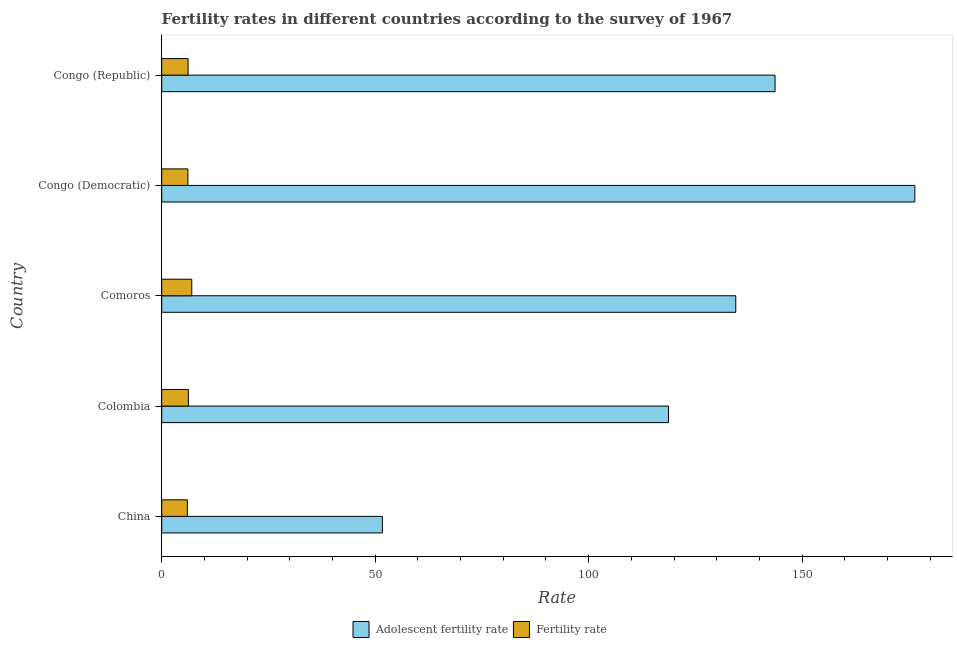How many different coloured bars are there?
Make the answer very short. 2. How many groups of bars are there?
Your response must be concise. 5. Are the number of bars on each tick of the Y-axis equal?
Provide a succinct answer. Yes. How many bars are there on the 2nd tick from the top?
Keep it short and to the point. 2. How many bars are there on the 2nd tick from the bottom?
Provide a succinct answer. 2. What is the label of the 3rd group of bars from the top?
Ensure brevity in your answer.  Comoros. What is the fertility rate in Congo (Democratic)?
Give a very brief answer. 6.13. Across all countries, what is the maximum adolescent fertility rate?
Offer a terse response. 176.4. Across all countries, what is the minimum adolescent fertility rate?
Your answer should be compact. 51.69. In which country was the fertility rate maximum?
Provide a short and direct response. Comoros. What is the total adolescent fertility rate in the graph?
Your response must be concise. 624.89. What is the difference between the adolescent fertility rate in Congo (Democratic) and that in Congo (Republic)?
Offer a very short reply. 32.74. What is the difference between the adolescent fertility rate in Colombia and the fertility rate in Congo (Republic)?
Give a very brief answer. 112.52. What is the average adolescent fertility rate per country?
Offer a very short reply. 124.98. What is the difference between the fertility rate and adolescent fertility rate in Congo (Republic)?
Your response must be concise. -137.48. What is the ratio of the adolescent fertility rate in Congo (Democratic) to that in Congo (Republic)?
Your response must be concise. 1.23. Is the difference between the fertility rate in Colombia and Comoros greater than the difference between the adolescent fertility rate in Colombia and Comoros?
Make the answer very short. Yes. What is the difference between the highest and the second highest fertility rate?
Your answer should be compact. 0.8. What is the difference between the highest and the lowest adolescent fertility rate?
Give a very brief answer. 124.71. In how many countries, is the adolescent fertility rate greater than the average adolescent fertility rate taken over all countries?
Give a very brief answer. 3. Is the sum of the adolescent fertility rate in Colombia and Comoros greater than the maximum fertility rate across all countries?
Your response must be concise. Yes. What does the 1st bar from the top in Comoros represents?
Make the answer very short. Fertility rate. What does the 1st bar from the bottom in Congo (Republic) represents?
Provide a succinct answer. Adolescent fertility rate. Are all the bars in the graph horizontal?
Ensure brevity in your answer.  Yes. How many countries are there in the graph?
Give a very brief answer. 5. How many legend labels are there?
Your answer should be compact. 2. How are the legend labels stacked?
Ensure brevity in your answer.  Horizontal. What is the title of the graph?
Your answer should be compact. Fertility rates in different countries according to the survey of 1967. What is the label or title of the X-axis?
Offer a very short reply. Rate. What is the Rate in Adolescent fertility rate in China?
Your answer should be compact. 51.69. What is the Rate in Fertility rate in China?
Your answer should be compact. 6.01. What is the Rate of Adolescent fertility rate in Colombia?
Give a very brief answer. 118.7. What is the Rate in Fertility rate in Colombia?
Make the answer very short. 6.25. What is the Rate of Adolescent fertility rate in Comoros?
Keep it short and to the point. 134.46. What is the Rate of Fertility rate in Comoros?
Make the answer very short. 7.04. What is the Rate in Adolescent fertility rate in Congo (Democratic)?
Make the answer very short. 176.4. What is the Rate of Fertility rate in Congo (Democratic)?
Make the answer very short. 6.13. What is the Rate of Adolescent fertility rate in Congo (Republic)?
Offer a very short reply. 143.65. What is the Rate in Fertility rate in Congo (Republic)?
Provide a succinct answer. 6.18. Across all countries, what is the maximum Rate of Adolescent fertility rate?
Make the answer very short. 176.4. Across all countries, what is the maximum Rate in Fertility rate?
Keep it short and to the point. 7.04. Across all countries, what is the minimum Rate of Adolescent fertility rate?
Your response must be concise. 51.69. Across all countries, what is the minimum Rate in Fertility rate?
Your response must be concise. 6.01. What is the total Rate of Adolescent fertility rate in the graph?
Your answer should be very brief. 624.89. What is the total Rate in Fertility rate in the graph?
Ensure brevity in your answer.  31.61. What is the difference between the Rate in Adolescent fertility rate in China and that in Colombia?
Offer a very short reply. -67.02. What is the difference between the Rate of Fertility rate in China and that in Colombia?
Offer a terse response. -0.23. What is the difference between the Rate in Adolescent fertility rate in China and that in Comoros?
Keep it short and to the point. -82.77. What is the difference between the Rate in Fertility rate in China and that in Comoros?
Your answer should be compact. -1.03. What is the difference between the Rate of Adolescent fertility rate in China and that in Congo (Democratic)?
Offer a very short reply. -124.71. What is the difference between the Rate of Fertility rate in China and that in Congo (Democratic)?
Ensure brevity in your answer.  -0.12. What is the difference between the Rate in Adolescent fertility rate in China and that in Congo (Republic)?
Your response must be concise. -91.97. What is the difference between the Rate of Fertility rate in China and that in Congo (Republic)?
Provide a short and direct response. -0.17. What is the difference between the Rate of Adolescent fertility rate in Colombia and that in Comoros?
Provide a succinct answer. -15.76. What is the difference between the Rate of Fertility rate in Colombia and that in Comoros?
Give a very brief answer. -0.8. What is the difference between the Rate in Adolescent fertility rate in Colombia and that in Congo (Democratic)?
Make the answer very short. -57.7. What is the difference between the Rate in Fertility rate in Colombia and that in Congo (Democratic)?
Offer a very short reply. 0.11. What is the difference between the Rate in Adolescent fertility rate in Colombia and that in Congo (Republic)?
Offer a very short reply. -24.95. What is the difference between the Rate in Fertility rate in Colombia and that in Congo (Republic)?
Offer a terse response. 0.07. What is the difference between the Rate of Adolescent fertility rate in Comoros and that in Congo (Democratic)?
Give a very brief answer. -41.94. What is the difference between the Rate in Fertility rate in Comoros and that in Congo (Democratic)?
Ensure brevity in your answer.  0.91. What is the difference between the Rate in Adolescent fertility rate in Comoros and that in Congo (Republic)?
Offer a terse response. -9.2. What is the difference between the Rate of Fertility rate in Comoros and that in Congo (Republic)?
Ensure brevity in your answer.  0.87. What is the difference between the Rate in Adolescent fertility rate in Congo (Democratic) and that in Congo (Republic)?
Your answer should be compact. 32.74. What is the difference between the Rate in Fertility rate in Congo (Democratic) and that in Congo (Republic)?
Your response must be concise. -0.04. What is the difference between the Rate in Adolescent fertility rate in China and the Rate in Fertility rate in Colombia?
Offer a terse response. 45.44. What is the difference between the Rate in Adolescent fertility rate in China and the Rate in Fertility rate in Comoros?
Provide a succinct answer. 44.64. What is the difference between the Rate of Adolescent fertility rate in China and the Rate of Fertility rate in Congo (Democratic)?
Give a very brief answer. 45.55. What is the difference between the Rate in Adolescent fertility rate in China and the Rate in Fertility rate in Congo (Republic)?
Offer a terse response. 45.51. What is the difference between the Rate in Adolescent fertility rate in Colombia and the Rate in Fertility rate in Comoros?
Offer a very short reply. 111.66. What is the difference between the Rate in Adolescent fertility rate in Colombia and the Rate in Fertility rate in Congo (Democratic)?
Ensure brevity in your answer.  112.56. What is the difference between the Rate in Adolescent fertility rate in Colombia and the Rate in Fertility rate in Congo (Republic)?
Provide a short and direct response. 112.52. What is the difference between the Rate of Adolescent fertility rate in Comoros and the Rate of Fertility rate in Congo (Democratic)?
Offer a terse response. 128.32. What is the difference between the Rate of Adolescent fertility rate in Comoros and the Rate of Fertility rate in Congo (Republic)?
Offer a very short reply. 128.28. What is the difference between the Rate of Adolescent fertility rate in Congo (Democratic) and the Rate of Fertility rate in Congo (Republic)?
Keep it short and to the point. 170.22. What is the average Rate of Adolescent fertility rate per country?
Your answer should be compact. 124.98. What is the average Rate of Fertility rate per country?
Offer a terse response. 6.32. What is the difference between the Rate of Adolescent fertility rate and Rate of Fertility rate in China?
Provide a succinct answer. 45.67. What is the difference between the Rate in Adolescent fertility rate and Rate in Fertility rate in Colombia?
Your answer should be very brief. 112.45. What is the difference between the Rate of Adolescent fertility rate and Rate of Fertility rate in Comoros?
Give a very brief answer. 127.41. What is the difference between the Rate of Adolescent fertility rate and Rate of Fertility rate in Congo (Democratic)?
Your answer should be very brief. 170.26. What is the difference between the Rate in Adolescent fertility rate and Rate in Fertility rate in Congo (Republic)?
Make the answer very short. 137.48. What is the ratio of the Rate in Adolescent fertility rate in China to that in Colombia?
Provide a short and direct response. 0.44. What is the ratio of the Rate in Fertility rate in China to that in Colombia?
Make the answer very short. 0.96. What is the ratio of the Rate of Adolescent fertility rate in China to that in Comoros?
Your response must be concise. 0.38. What is the ratio of the Rate in Fertility rate in China to that in Comoros?
Your answer should be compact. 0.85. What is the ratio of the Rate of Adolescent fertility rate in China to that in Congo (Democratic)?
Make the answer very short. 0.29. What is the ratio of the Rate of Fertility rate in China to that in Congo (Democratic)?
Give a very brief answer. 0.98. What is the ratio of the Rate of Adolescent fertility rate in China to that in Congo (Republic)?
Keep it short and to the point. 0.36. What is the ratio of the Rate in Fertility rate in China to that in Congo (Republic)?
Offer a terse response. 0.97. What is the ratio of the Rate of Adolescent fertility rate in Colombia to that in Comoros?
Offer a terse response. 0.88. What is the ratio of the Rate of Fertility rate in Colombia to that in Comoros?
Provide a succinct answer. 0.89. What is the ratio of the Rate in Adolescent fertility rate in Colombia to that in Congo (Democratic)?
Offer a terse response. 0.67. What is the ratio of the Rate of Fertility rate in Colombia to that in Congo (Democratic)?
Your answer should be very brief. 1.02. What is the ratio of the Rate of Adolescent fertility rate in Colombia to that in Congo (Republic)?
Give a very brief answer. 0.83. What is the ratio of the Rate of Fertility rate in Colombia to that in Congo (Republic)?
Keep it short and to the point. 1.01. What is the ratio of the Rate in Adolescent fertility rate in Comoros to that in Congo (Democratic)?
Your answer should be compact. 0.76. What is the ratio of the Rate in Fertility rate in Comoros to that in Congo (Democratic)?
Make the answer very short. 1.15. What is the ratio of the Rate in Adolescent fertility rate in Comoros to that in Congo (Republic)?
Offer a very short reply. 0.94. What is the ratio of the Rate in Fertility rate in Comoros to that in Congo (Republic)?
Make the answer very short. 1.14. What is the ratio of the Rate of Adolescent fertility rate in Congo (Democratic) to that in Congo (Republic)?
Give a very brief answer. 1.23. What is the difference between the highest and the second highest Rate of Adolescent fertility rate?
Your answer should be compact. 32.74. What is the difference between the highest and the second highest Rate in Fertility rate?
Offer a very short reply. 0.8. What is the difference between the highest and the lowest Rate of Adolescent fertility rate?
Give a very brief answer. 124.71. What is the difference between the highest and the lowest Rate of Fertility rate?
Your response must be concise. 1.03. 